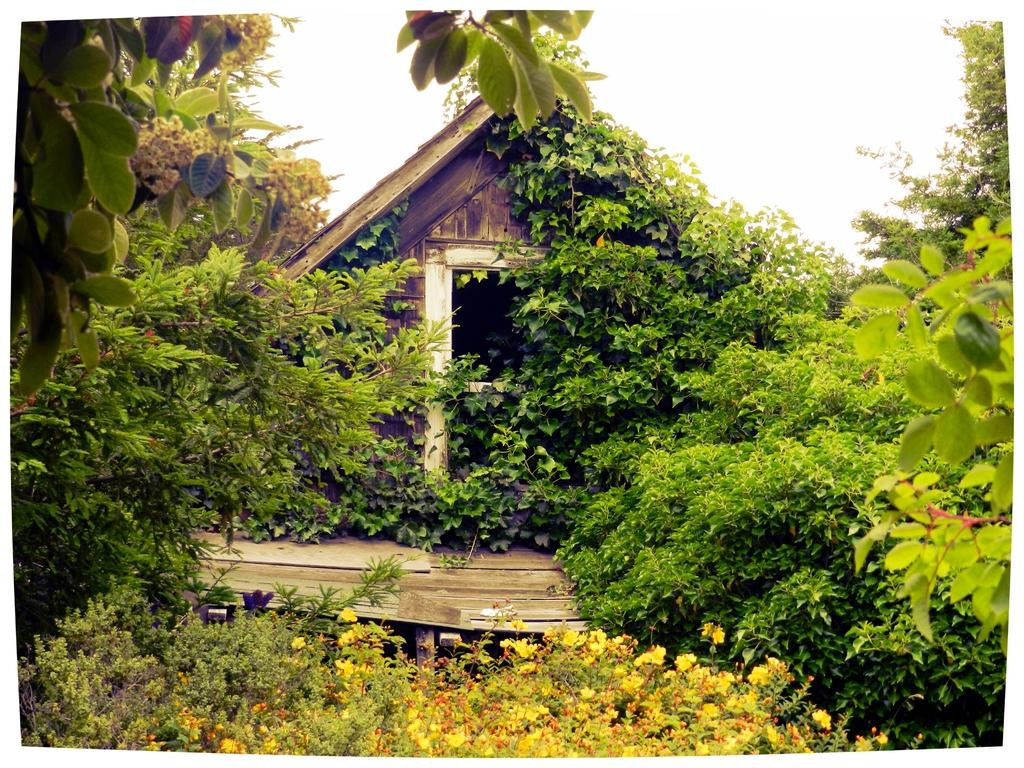What type of structure is visible in the picture? There is a house in the picture. What other natural elements can be seen in the picture? There are trees in the picture. How would you describe the weather based on the sky in the picture? The sky is cloudy in the picture. How many books are stacked on the roof of the house in the picture? There are no books visible on the roof of the house in the picture. 